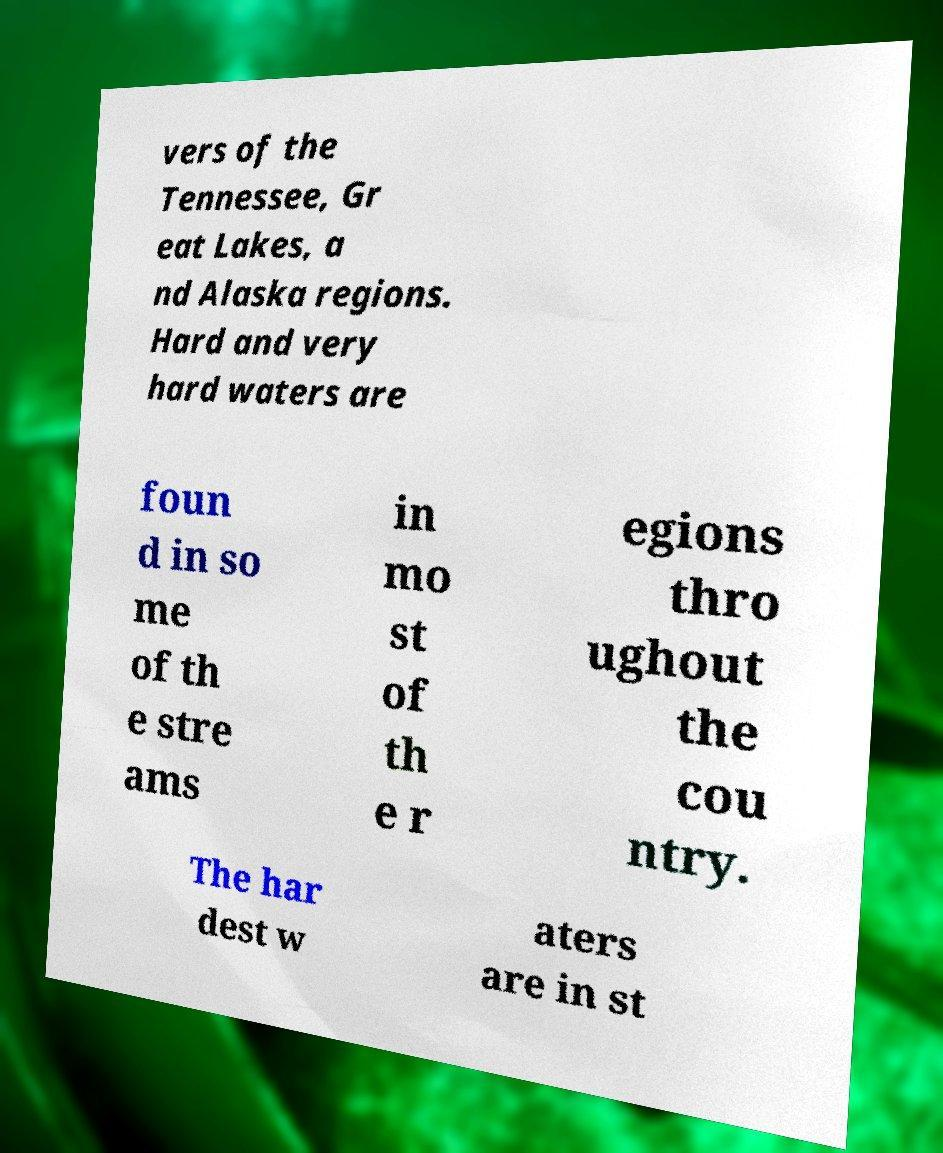Please identify and transcribe the text found in this image. vers of the Tennessee, Gr eat Lakes, a nd Alaska regions. Hard and very hard waters are foun d in so me of th e stre ams in mo st of th e r egions thro ughout the cou ntry. The har dest w aters are in st 